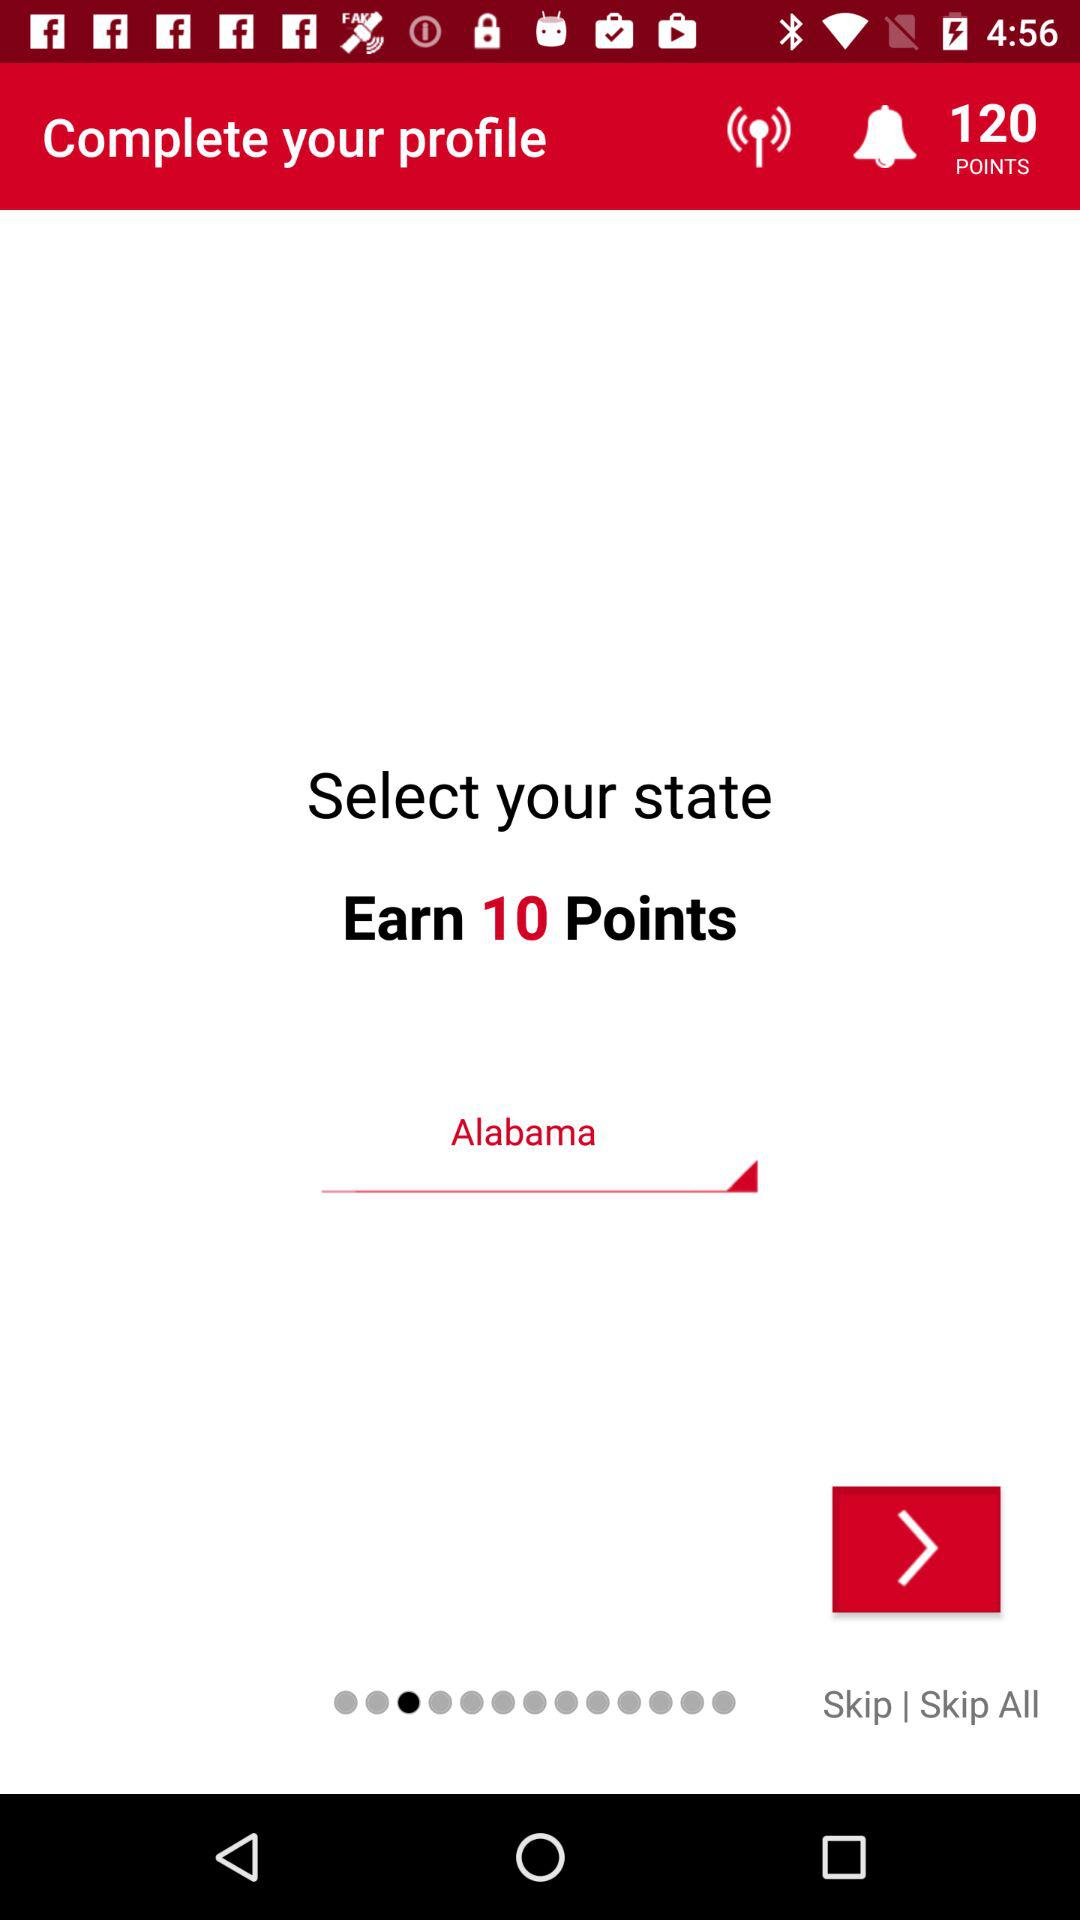Which state is selected? The selected state is Alabama. 